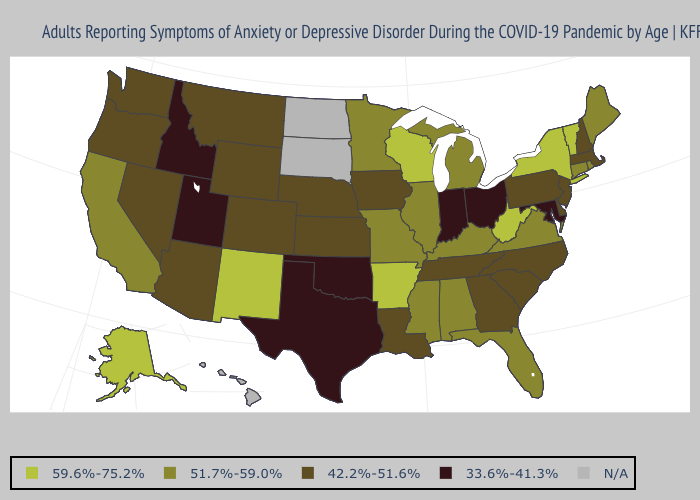Name the states that have a value in the range 33.6%-41.3%?
Be succinct. Idaho, Indiana, Maryland, Ohio, Oklahoma, Texas, Utah. Which states have the lowest value in the West?
Quick response, please. Idaho, Utah. Which states have the highest value in the USA?
Quick response, please. Alaska, Arkansas, New Mexico, New York, Vermont, West Virginia, Wisconsin. Which states hav the highest value in the South?
Give a very brief answer. Arkansas, West Virginia. Does Idaho have the lowest value in the USA?
Quick response, please. Yes. Is the legend a continuous bar?
Short answer required. No. Name the states that have a value in the range 42.2%-51.6%?
Quick response, please. Arizona, Colorado, Delaware, Georgia, Iowa, Kansas, Louisiana, Massachusetts, Montana, Nebraska, Nevada, New Hampshire, New Jersey, North Carolina, Oregon, Pennsylvania, South Carolina, Tennessee, Washington, Wyoming. Does Michigan have the highest value in the MidWest?
Quick response, please. No. Is the legend a continuous bar?
Keep it brief. No. Name the states that have a value in the range N/A?
Give a very brief answer. Hawaii, North Dakota, South Dakota. Is the legend a continuous bar?
Quick response, please. No. Does the map have missing data?
Write a very short answer. Yes. Does Minnesota have the lowest value in the MidWest?
Give a very brief answer. No. 